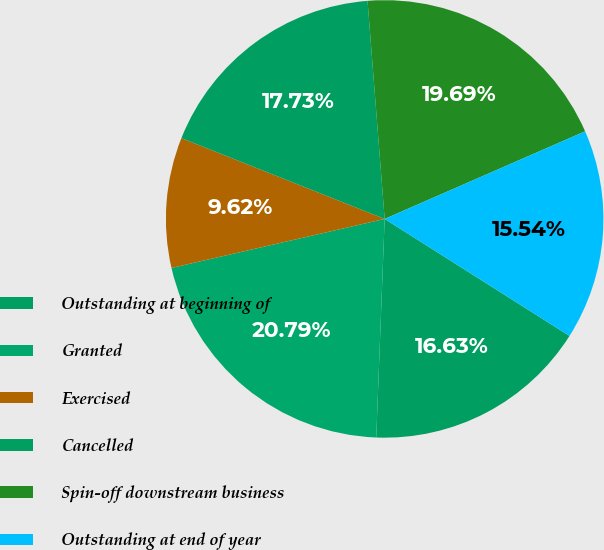<chart> <loc_0><loc_0><loc_500><loc_500><pie_chart><fcel>Outstanding at beginning of<fcel>Granted<fcel>Exercised<fcel>Cancelled<fcel>Spin-off downstream business<fcel>Outstanding at end of year<nl><fcel>16.63%<fcel>20.79%<fcel>9.62%<fcel>17.73%<fcel>19.69%<fcel>15.54%<nl></chart> 